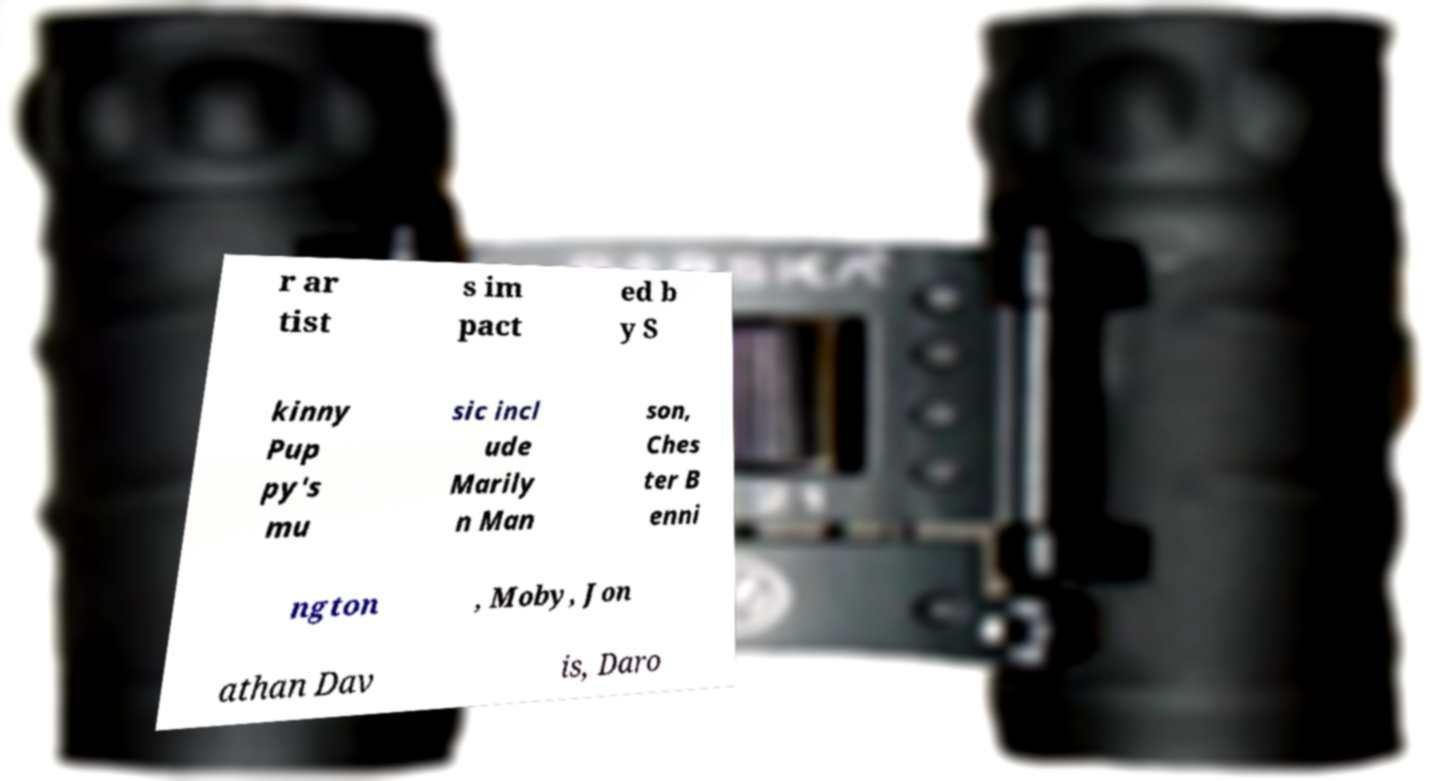Can you read and provide the text displayed in the image?This photo seems to have some interesting text. Can you extract and type it out for me? r ar tist s im pact ed b y S kinny Pup py's mu sic incl ude Marily n Man son, Ches ter B enni ngton , Moby, Jon athan Dav is, Daro 